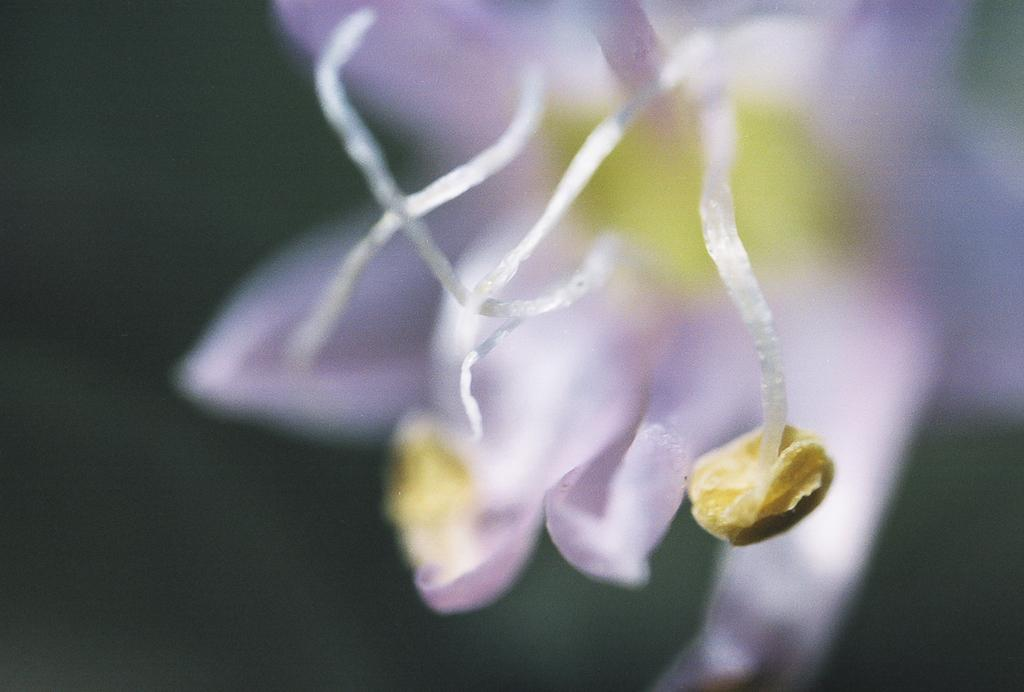What is the main subject of the image? There is a flower in the image. What colors can be seen on the flower? The flower has yellow and purple colors. What color is the background of the image? The background of the image is black. How would you describe the quality of the image? The image is blurred. Where is the shelf located in the image? There is no shelf present in the image. Can you see a zebra playing basketball in the image? There is no zebra or basketball present in the image. 